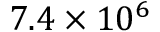Convert formula to latex. <formula><loc_0><loc_0><loc_500><loc_500>7 . 4 \times 1 0 ^ { 6 }</formula> 